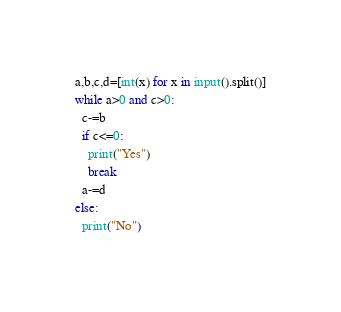<code> <loc_0><loc_0><loc_500><loc_500><_Python_>a,b,c,d=[int(x) for x in input().split()]
while a>0 and c>0:
  c-=b
  if c<=0:
    print("Yes")
    break
  a-=d
else:
  print("No")</code> 